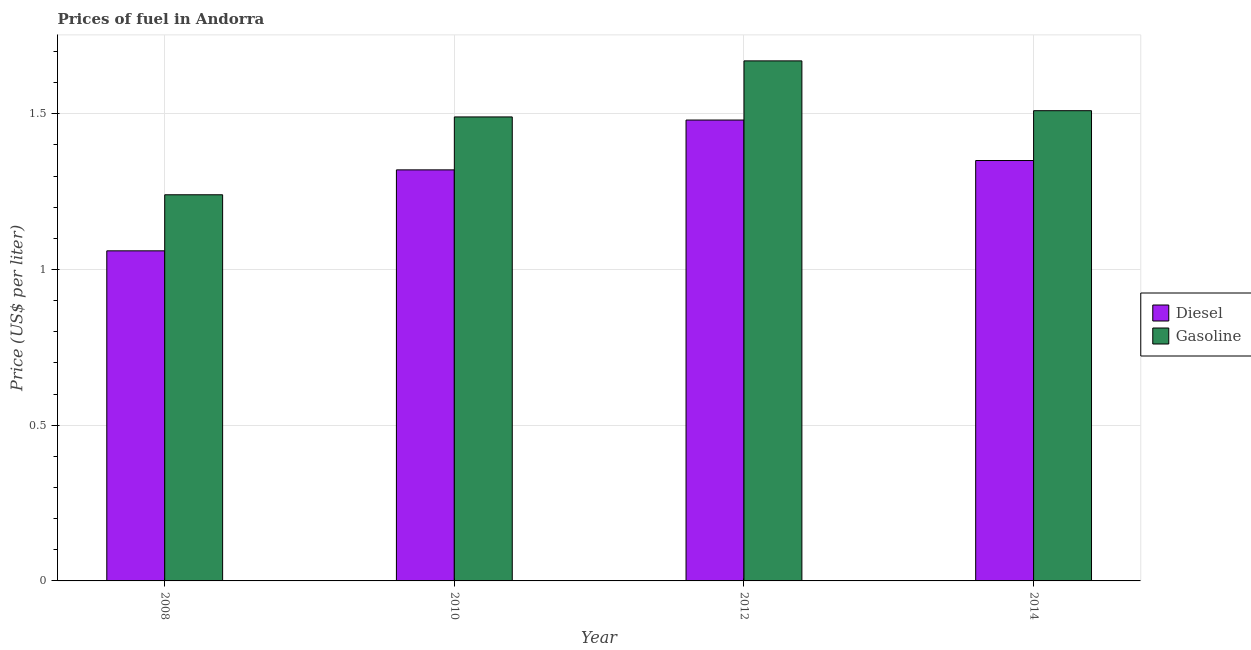How many different coloured bars are there?
Ensure brevity in your answer.  2. Are the number of bars per tick equal to the number of legend labels?
Your answer should be very brief. Yes. Are the number of bars on each tick of the X-axis equal?
Your response must be concise. Yes. How many bars are there on the 4th tick from the left?
Ensure brevity in your answer.  2. How many bars are there on the 4th tick from the right?
Keep it short and to the point. 2. In how many cases, is the number of bars for a given year not equal to the number of legend labels?
Offer a very short reply. 0. What is the gasoline price in 2012?
Provide a short and direct response. 1.67. Across all years, what is the maximum gasoline price?
Offer a very short reply. 1.67. Across all years, what is the minimum gasoline price?
Give a very brief answer. 1.24. What is the total gasoline price in the graph?
Offer a terse response. 5.91. What is the difference between the diesel price in 2008 and that in 2010?
Your response must be concise. -0.26. What is the difference between the diesel price in 2008 and the gasoline price in 2010?
Your answer should be compact. -0.26. What is the average gasoline price per year?
Provide a short and direct response. 1.48. In how many years, is the diesel price greater than 0.7 US$ per litre?
Offer a terse response. 4. What is the ratio of the gasoline price in 2012 to that in 2014?
Your answer should be very brief. 1.11. Is the diesel price in 2012 less than that in 2014?
Offer a terse response. No. Is the difference between the gasoline price in 2008 and 2014 greater than the difference between the diesel price in 2008 and 2014?
Offer a terse response. No. What is the difference between the highest and the second highest gasoline price?
Your answer should be very brief. 0.16. What is the difference between the highest and the lowest gasoline price?
Make the answer very short. 0.43. In how many years, is the diesel price greater than the average diesel price taken over all years?
Offer a very short reply. 3. What does the 1st bar from the left in 2014 represents?
Provide a succinct answer. Diesel. What does the 2nd bar from the right in 2012 represents?
Offer a very short reply. Diesel. Are all the bars in the graph horizontal?
Offer a terse response. No. How many years are there in the graph?
Give a very brief answer. 4. Does the graph contain grids?
Your response must be concise. Yes. Where does the legend appear in the graph?
Your answer should be very brief. Center right. What is the title of the graph?
Provide a succinct answer. Prices of fuel in Andorra. Does "Young" appear as one of the legend labels in the graph?
Give a very brief answer. No. What is the label or title of the X-axis?
Provide a succinct answer. Year. What is the label or title of the Y-axis?
Give a very brief answer. Price (US$ per liter). What is the Price (US$ per liter) in Diesel in 2008?
Provide a short and direct response. 1.06. What is the Price (US$ per liter) in Gasoline in 2008?
Give a very brief answer. 1.24. What is the Price (US$ per liter) of Diesel in 2010?
Make the answer very short. 1.32. What is the Price (US$ per liter) of Gasoline in 2010?
Your answer should be compact. 1.49. What is the Price (US$ per liter) of Diesel in 2012?
Give a very brief answer. 1.48. What is the Price (US$ per liter) of Gasoline in 2012?
Provide a succinct answer. 1.67. What is the Price (US$ per liter) of Diesel in 2014?
Make the answer very short. 1.35. What is the Price (US$ per liter) of Gasoline in 2014?
Offer a very short reply. 1.51. Across all years, what is the maximum Price (US$ per liter) in Diesel?
Give a very brief answer. 1.48. Across all years, what is the maximum Price (US$ per liter) of Gasoline?
Provide a succinct answer. 1.67. Across all years, what is the minimum Price (US$ per liter) of Diesel?
Offer a very short reply. 1.06. Across all years, what is the minimum Price (US$ per liter) in Gasoline?
Your answer should be compact. 1.24. What is the total Price (US$ per liter) of Diesel in the graph?
Your response must be concise. 5.21. What is the total Price (US$ per liter) of Gasoline in the graph?
Offer a terse response. 5.91. What is the difference between the Price (US$ per liter) in Diesel in 2008 and that in 2010?
Keep it short and to the point. -0.26. What is the difference between the Price (US$ per liter) in Diesel in 2008 and that in 2012?
Your answer should be compact. -0.42. What is the difference between the Price (US$ per liter) in Gasoline in 2008 and that in 2012?
Your answer should be very brief. -0.43. What is the difference between the Price (US$ per liter) in Diesel in 2008 and that in 2014?
Give a very brief answer. -0.29. What is the difference between the Price (US$ per liter) in Gasoline in 2008 and that in 2014?
Offer a very short reply. -0.27. What is the difference between the Price (US$ per liter) in Diesel in 2010 and that in 2012?
Keep it short and to the point. -0.16. What is the difference between the Price (US$ per liter) in Gasoline in 2010 and that in 2012?
Ensure brevity in your answer.  -0.18. What is the difference between the Price (US$ per liter) of Diesel in 2010 and that in 2014?
Provide a succinct answer. -0.03. What is the difference between the Price (US$ per liter) of Gasoline in 2010 and that in 2014?
Offer a very short reply. -0.02. What is the difference between the Price (US$ per liter) in Diesel in 2012 and that in 2014?
Provide a succinct answer. 0.13. What is the difference between the Price (US$ per liter) of Gasoline in 2012 and that in 2014?
Make the answer very short. 0.16. What is the difference between the Price (US$ per liter) of Diesel in 2008 and the Price (US$ per liter) of Gasoline in 2010?
Keep it short and to the point. -0.43. What is the difference between the Price (US$ per liter) in Diesel in 2008 and the Price (US$ per liter) in Gasoline in 2012?
Your answer should be very brief. -0.61. What is the difference between the Price (US$ per liter) in Diesel in 2008 and the Price (US$ per liter) in Gasoline in 2014?
Provide a short and direct response. -0.45. What is the difference between the Price (US$ per liter) of Diesel in 2010 and the Price (US$ per liter) of Gasoline in 2012?
Give a very brief answer. -0.35. What is the difference between the Price (US$ per liter) of Diesel in 2010 and the Price (US$ per liter) of Gasoline in 2014?
Keep it short and to the point. -0.19. What is the difference between the Price (US$ per liter) of Diesel in 2012 and the Price (US$ per liter) of Gasoline in 2014?
Offer a very short reply. -0.03. What is the average Price (US$ per liter) of Diesel per year?
Make the answer very short. 1.3. What is the average Price (US$ per liter) of Gasoline per year?
Your answer should be very brief. 1.48. In the year 2008, what is the difference between the Price (US$ per liter) of Diesel and Price (US$ per liter) of Gasoline?
Your answer should be very brief. -0.18. In the year 2010, what is the difference between the Price (US$ per liter) of Diesel and Price (US$ per liter) of Gasoline?
Ensure brevity in your answer.  -0.17. In the year 2012, what is the difference between the Price (US$ per liter) in Diesel and Price (US$ per liter) in Gasoline?
Your answer should be compact. -0.19. In the year 2014, what is the difference between the Price (US$ per liter) of Diesel and Price (US$ per liter) of Gasoline?
Give a very brief answer. -0.16. What is the ratio of the Price (US$ per liter) in Diesel in 2008 to that in 2010?
Your answer should be very brief. 0.8. What is the ratio of the Price (US$ per liter) in Gasoline in 2008 to that in 2010?
Your response must be concise. 0.83. What is the ratio of the Price (US$ per liter) in Diesel in 2008 to that in 2012?
Your response must be concise. 0.72. What is the ratio of the Price (US$ per liter) in Gasoline in 2008 to that in 2012?
Provide a succinct answer. 0.74. What is the ratio of the Price (US$ per liter) in Diesel in 2008 to that in 2014?
Your answer should be very brief. 0.79. What is the ratio of the Price (US$ per liter) of Gasoline in 2008 to that in 2014?
Provide a succinct answer. 0.82. What is the ratio of the Price (US$ per liter) of Diesel in 2010 to that in 2012?
Offer a very short reply. 0.89. What is the ratio of the Price (US$ per liter) of Gasoline in 2010 to that in 2012?
Provide a succinct answer. 0.89. What is the ratio of the Price (US$ per liter) in Diesel in 2010 to that in 2014?
Give a very brief answer. 0.98. What is the ratio of the Price (US$ per liter) in Gasoline in 2010 to that in 2014?
Keep it short and to the point. 0.99. What is the ratio of the Price (US$ per liter) of Diesel in 2012 to that in 2014?
Ensure brevity in your answer.  1.1. What is the ratio of the Price (US$ per liter) of Gasoline in 2012 to that in 2014?
Your answer should be very brief. 1.11. What is the difference between the highest and the second highest Price (US$ per liter) of Diesel?
Give a very brief answer. 0.13. What is the difference between the highest and the second highest Price (US$ per liter) of Gasoline?
Your response must be concise. 0.16. What is the difference between the highest and the lowest Price (US$ per liter) in Diesel?
Give a very brief answer. 0.42. What is the difference between the highest and the lowest Price (US$ per liter) in Gasoline?
Provide a short and direct response. 0.43. 